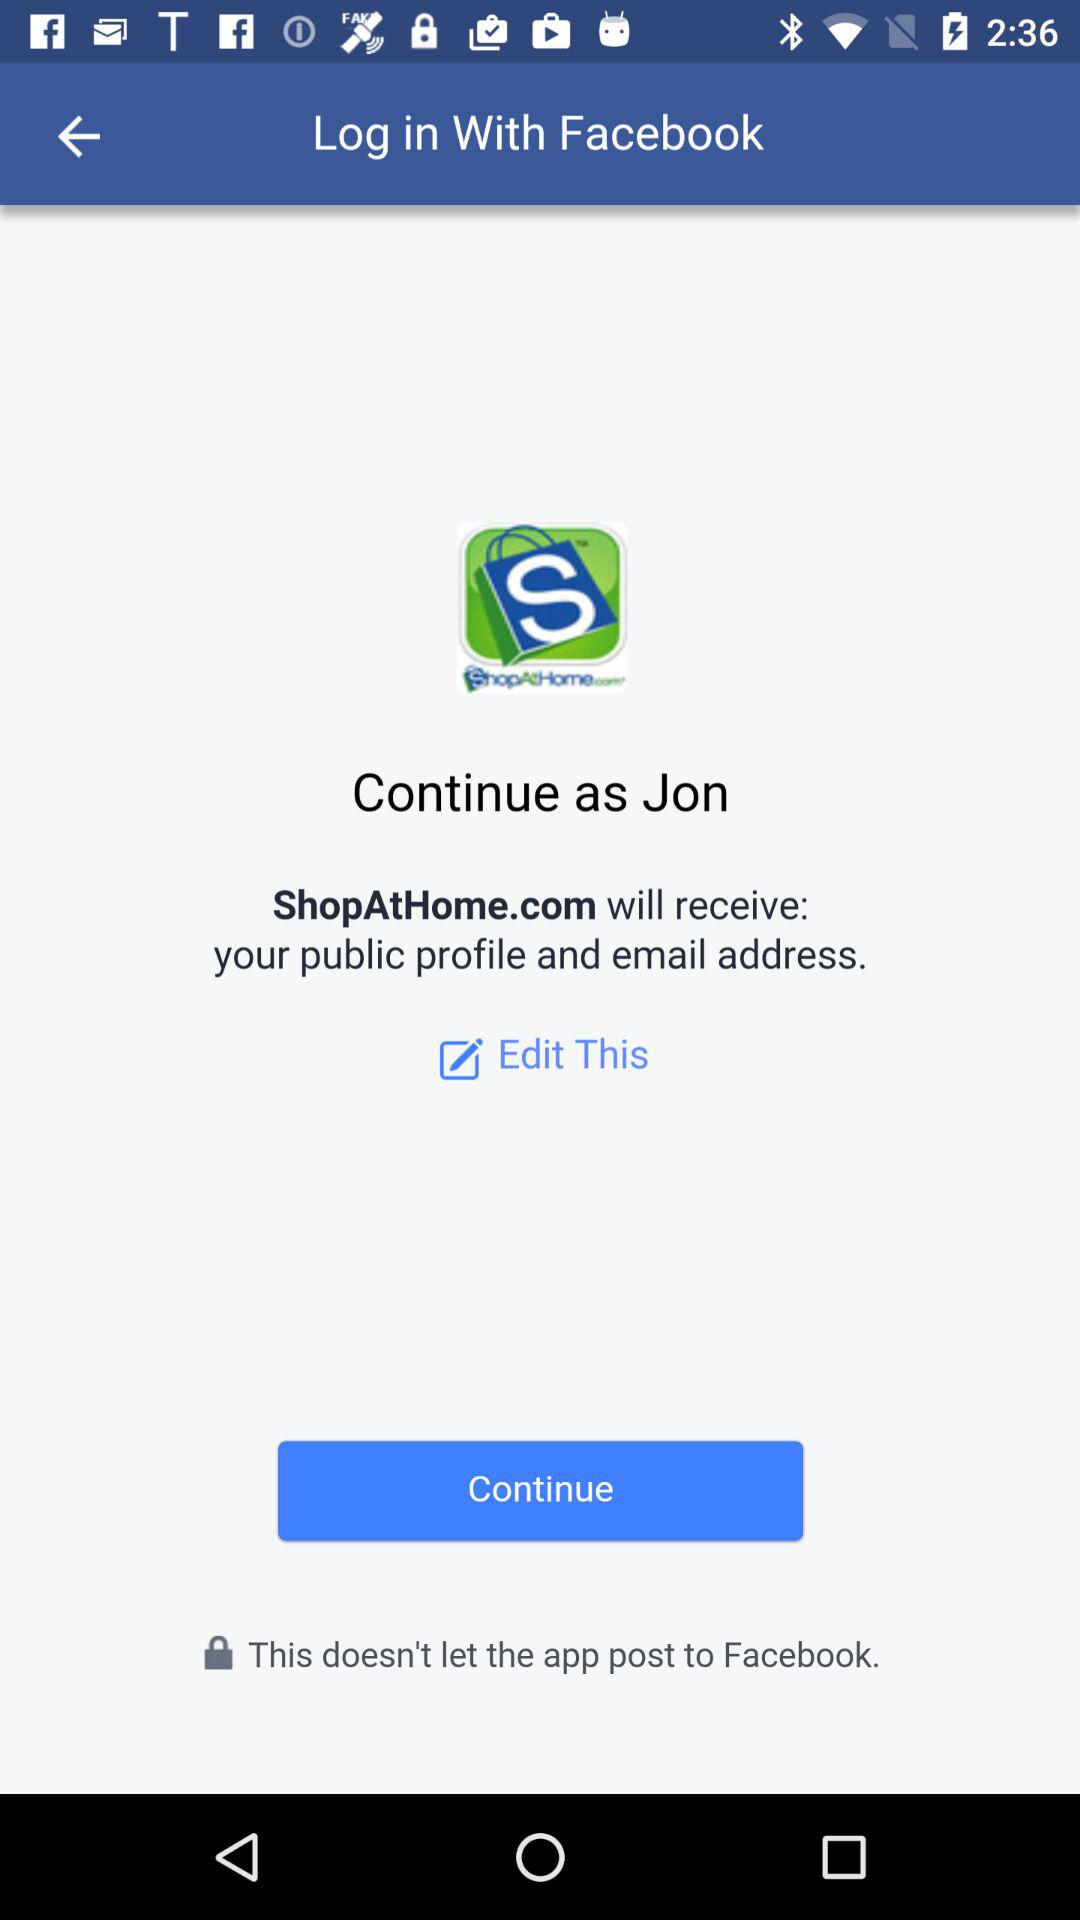What is the login name? The name is "Jon". 